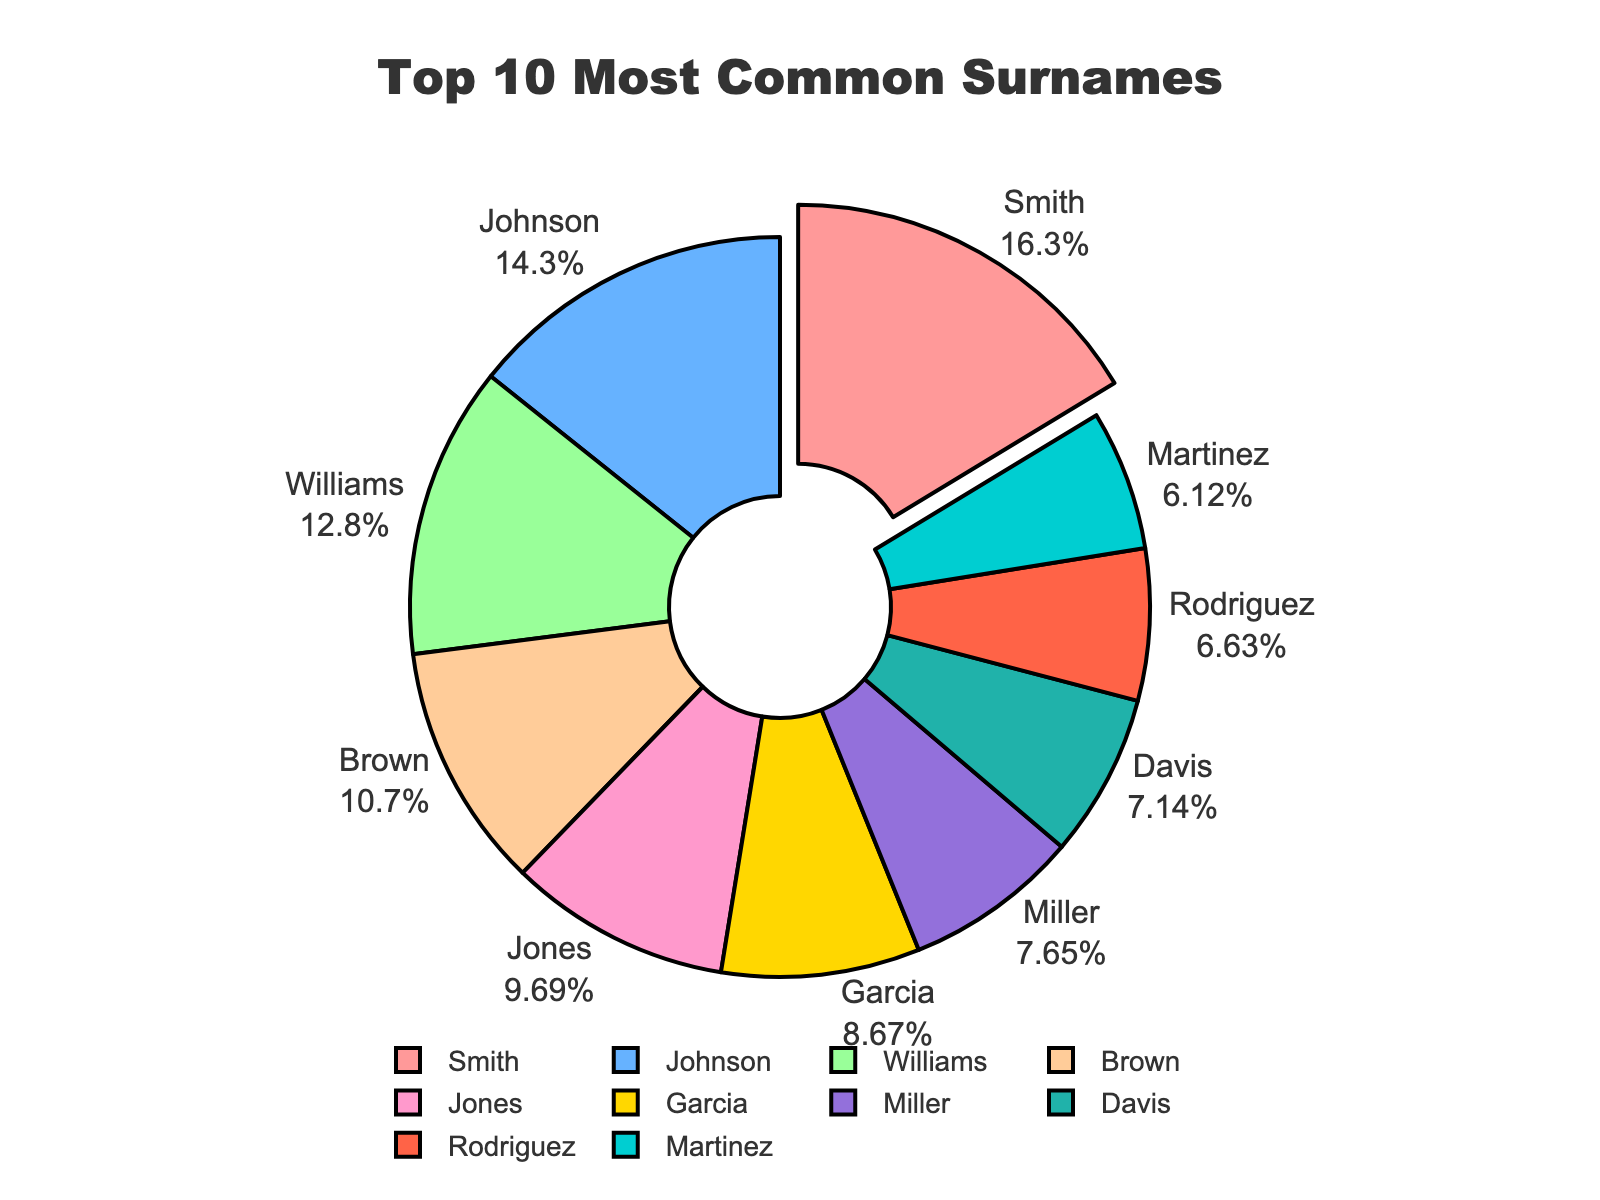Which surname has the highest percentage? Smith has the highest percentage. It stands out in the pie chart by being the largest segment and is also the only segment pulled out slightly from the rest.
Answer: Smith What is the total percentage of Garcia, Miller, Davis, Rodriguez, and Martinez combined? By adding their percentages: Garcia (1.7%) + Miller (1.5%) + Davis (1.4%) + Rodriguez (1.3%) + Martinez (1.2%) = 7.1%.
Answer: 7.1% Which surname has a larger percentage, Johnson or Williams? Comparing their segments, Johnson has 2.8% while Williams has 2.5%. Therefore, Johnson has a larger percentage.
Answer: Johnson Is the percentage of Brown greater than or less than 2%? The chart indicates that Brown has 2.1%, which is greater than 2%.
Answer: Greater than What fraction of the total percentage do the top three surnames (Smith, Johnson, Williams) represent? Adding their percentages: Smith (3.2%) + Johnson (2.8%) + Williams (2.5%) = 8.5%. Thus, they represent 8.5% of the total.
Answer: 8.5% Which surnames appear between the 1% - 2% range? Based on the pie chart, the surnames Jones (1.9%), Garcia (1.7%), Miller (1.5%), Davis (1.4%), Rodriguez (1.3%), and Martinez (1.2%) fall within 1% to 2%.
Answer: Jones, Garcia, Miller, Davis, Rodriguez, Martinez Is Williams closer in percentage to Johnson or Brown? Williams has 2.5%. The difference with Johnson (2.8%) is 0.3%, and with Brown (2.1%) it is 0.4%. Thus, Williams is closer in percentage to Johnson.
Answer: Johnson What is the average percentage of the surnames with more than 2% each? The surnames with more than 2% are Smith (3.2%), Johnson (2.8%), Williams (2.5%), and Brown (2.1%). The average is calculated by (3.2% + 2.8% + 2.5% + 2.1%) / 4 = 2.65%.
Answer: 2.65% What color represents the surname Martinez in the pie chart? Martinez is represented in light blue color in the pie chart.
Answer: Light blue 